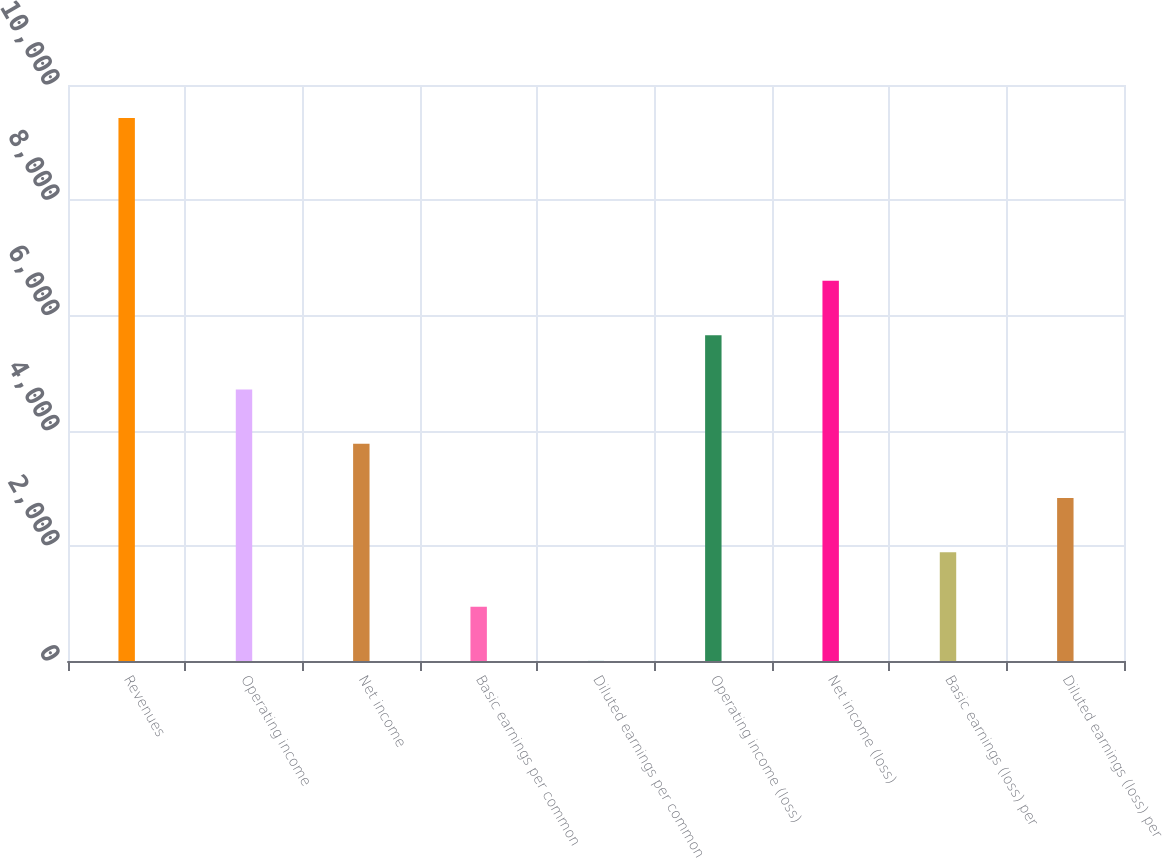Convert chart. <chart><loc_0><loc_0><loc_500><loc_500><bar_chart><fcel>Revenues<fcel>Operating income<fcel>Net income<fcel>Basic earnings per common<fcel>Diluted earnings per common<fcel>Operating income (loss)<fcel>Net income (loss)<fcel>Basic earnings (loss) per<fcel>Diluted earnings (loss) per<nl><fcel>9428<fcel>4714.68<fcel>3772.01<fcel>944<fcel>1.33<fcel>5657.35<fcel>6600.02<fcel>1886.67<fcel>2829.34<nl></chart> 